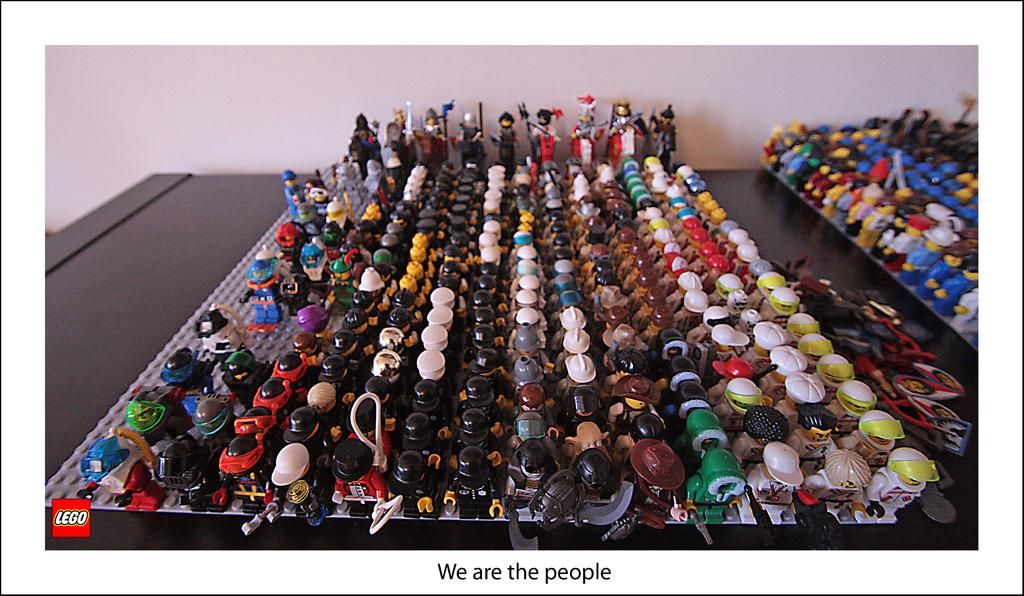What type of toys are in the image? There are small dolls and puppets in the image. Where are the dolls and puppets located? The dolls and puppets are on a desk. What is the color of the desk? The desk is black in color. What can be seen in the background of the image? There is a wall visible in the background of the image. How many trees can be seen in the image growing on the desk in the image? There are no trees visible on the desk in the image. Is there a volleyball being used by the dolls and puppets in the image? There is no volleyball present in the image. 